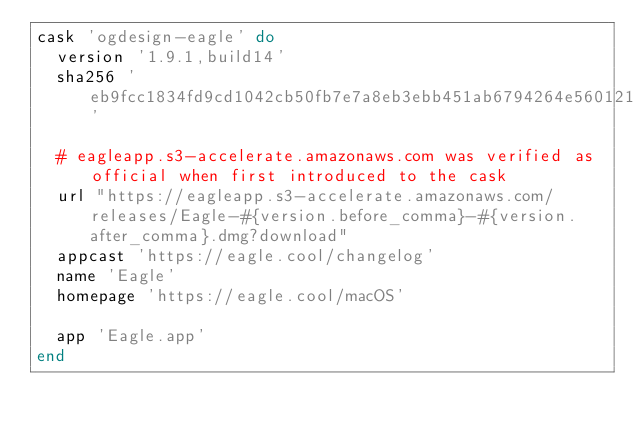<code> <loc_0><loc_0><loc_500><loc_500><_Ruby_>cask 'ogdesign-eagle' do
  version '1.9.1,build14'
  sha256 'eb9fcc1834fd9cd1042cb50fb7e7a8eb3ebb451ab6794264e56012180d06be21'

  # eagleapp.s3-accelerate.amazonaws.com was verified as official when first introduced to the cask
  url "https://eagleapp.s3-accelerate.amazonaws.com/releases/Eagle-#{version.before_comma}-#{version.after_comma}.dmg?download"
  appcast 'https://eagle.cool/changelog'
  name 'Eagle'
  homepage 'https://eagle.cool/macOS'

  app 'Eagle.app'
end
</code> 